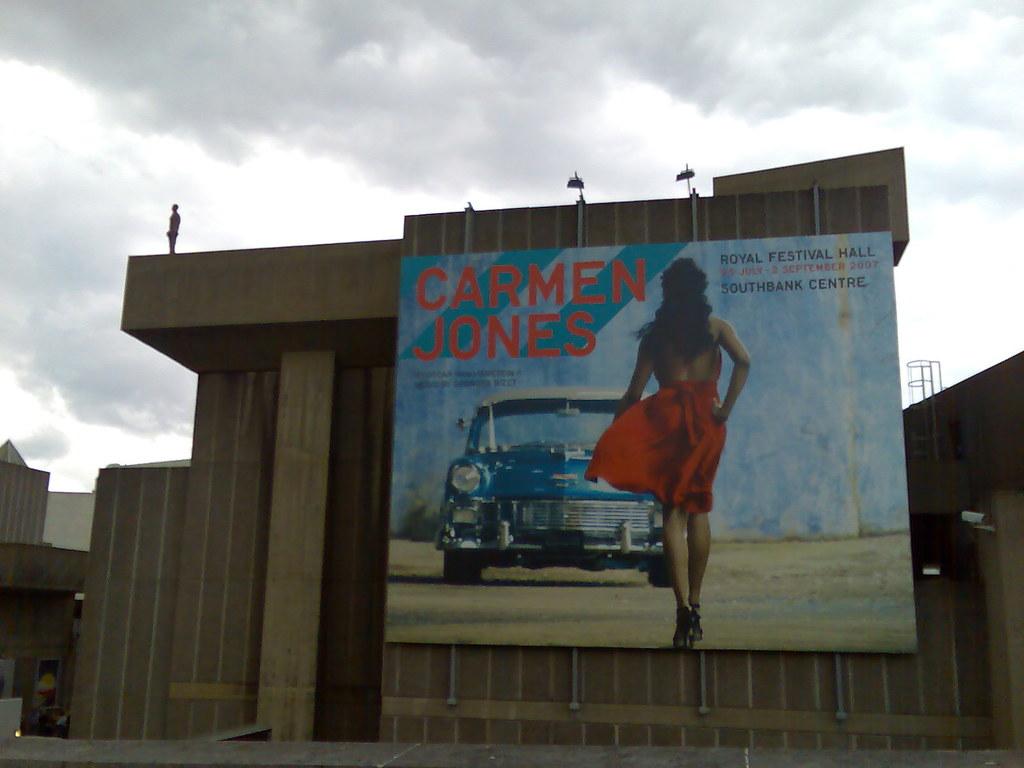Where is the first place listed to see carmen jones?
Provide a short and direct response. Royal festival hall. 